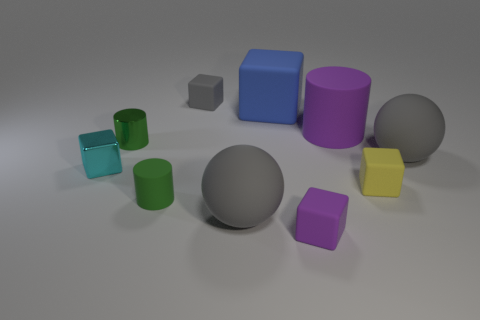Can you describe the relative sizes and colors of the objects in the image? Certainly! In the image, there are a variety of geometric shapes. Starting from the largest, there's a grey sphere in the center. Flanking it are two cylinders, one purple and one blue, with the blue one being slightly larger. There are also two small cubes: a yellow one and a purple one. Completing the set are three small cylinders in varying shades of green and blue. 